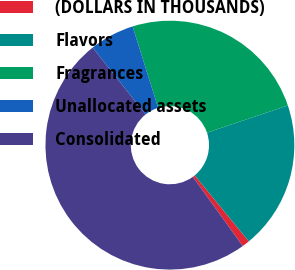Convert chart to OTSL. <chart><loc_0><loc_0><loc_500><loc_500><pie_chart><fcel>(DOLLARS IN THOUSANDS)<fcel>Flavors<fcel>Fragrances<fcel>Unallocated assets<fcel>Consolidated<nl><fcel>0.98%<fcel>19.23%<fcel>24.68%<fcel>5.81%<fcel>49.29%<nl></chart> 